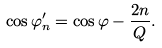<formula> <loc_0><loc_0><loc_500><loc_500>\cos \varphi _ { n } ^ { \prime } = \cos \varphi - \frac { 2 n } { Q } .</formula> 